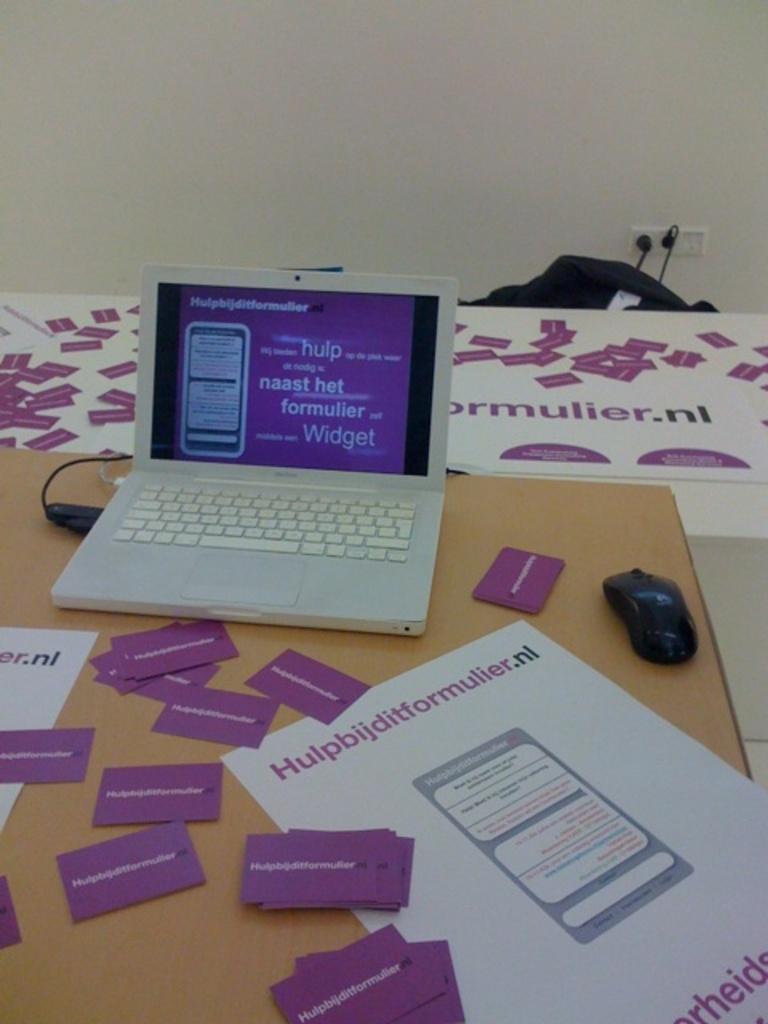What is the main color of the business cards?
Provide a short and direct response. Answering does not require reading text in the image. What is written on the screen?
Offer a very short reply. Widget. 